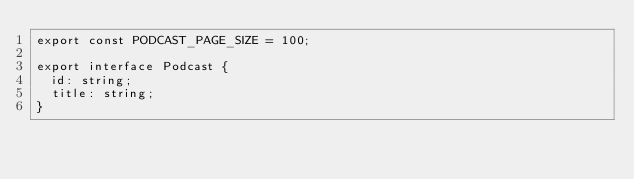<code> <loc_0><loc_0><loc_500><loc_500><_TypeScript_>export const PODCAST_PAGE_SIZE = 100;

export interface Podcast {
  id: string;
  title: string;
}
</code> 